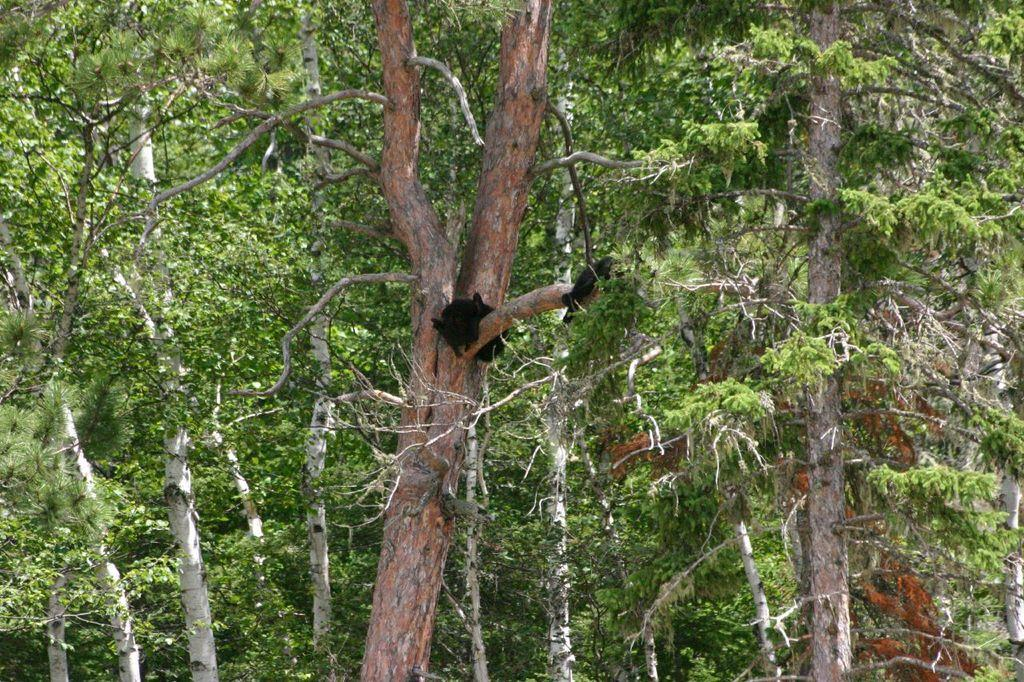What is the primary feature of the image? The primary feature of the image is the presence of many trees. Can you describe any specific objects or features on the trees? Yes, there is a black color thing on one of the trees. Based on the abundance of trees, where might this image have been taken? The image might have been taken in a forest, given the presence of many trees. What type of plants can be seen growing on the uncle's channel in the image? There is no uncle or channel present in the image, and therefore no such plants can be observed. 